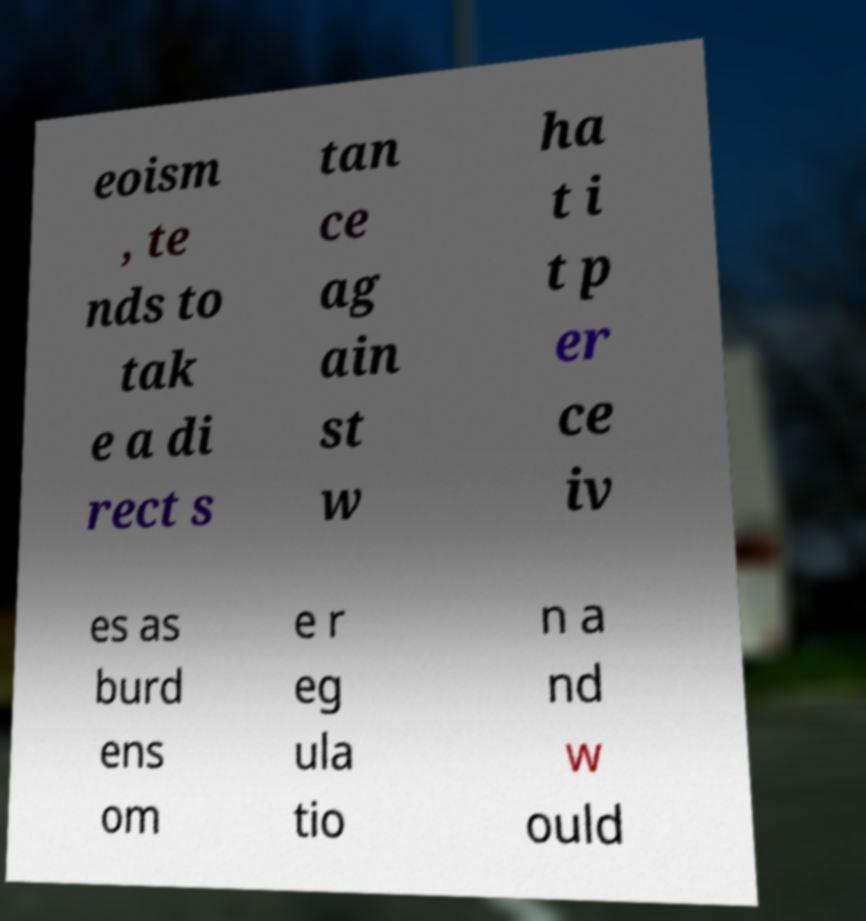Can you read and provide the text displayed in the image?This photo seems to have some interesting text. Can you extract and type it out for me? eoism , te nds to tak e a di rect s tan ce ag ain st w ha t i t p er ce iv es as burd ens om e r eg ula tio n a nd w ould 